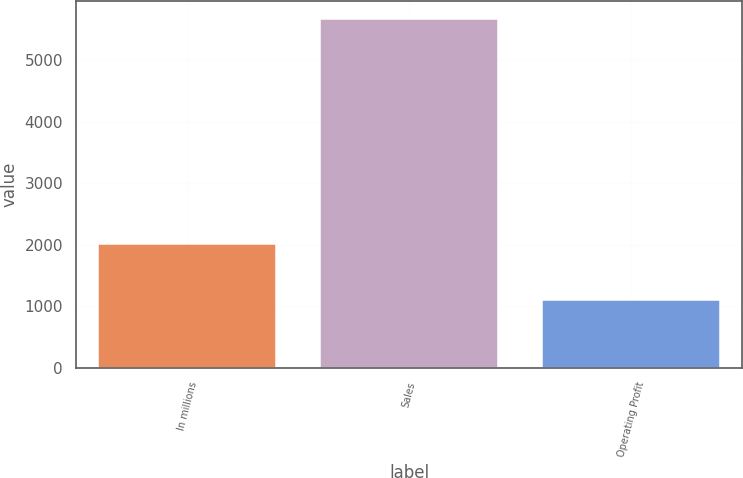Convert chart. <chart><loc_0><loc_0><loc_500><loc_500><bar_chart><fcel>In millions<fcel>Sales<fcel>Operating Profit<nl><fcel>2009<fcel>5680<fcel>1091<nl></chart> 